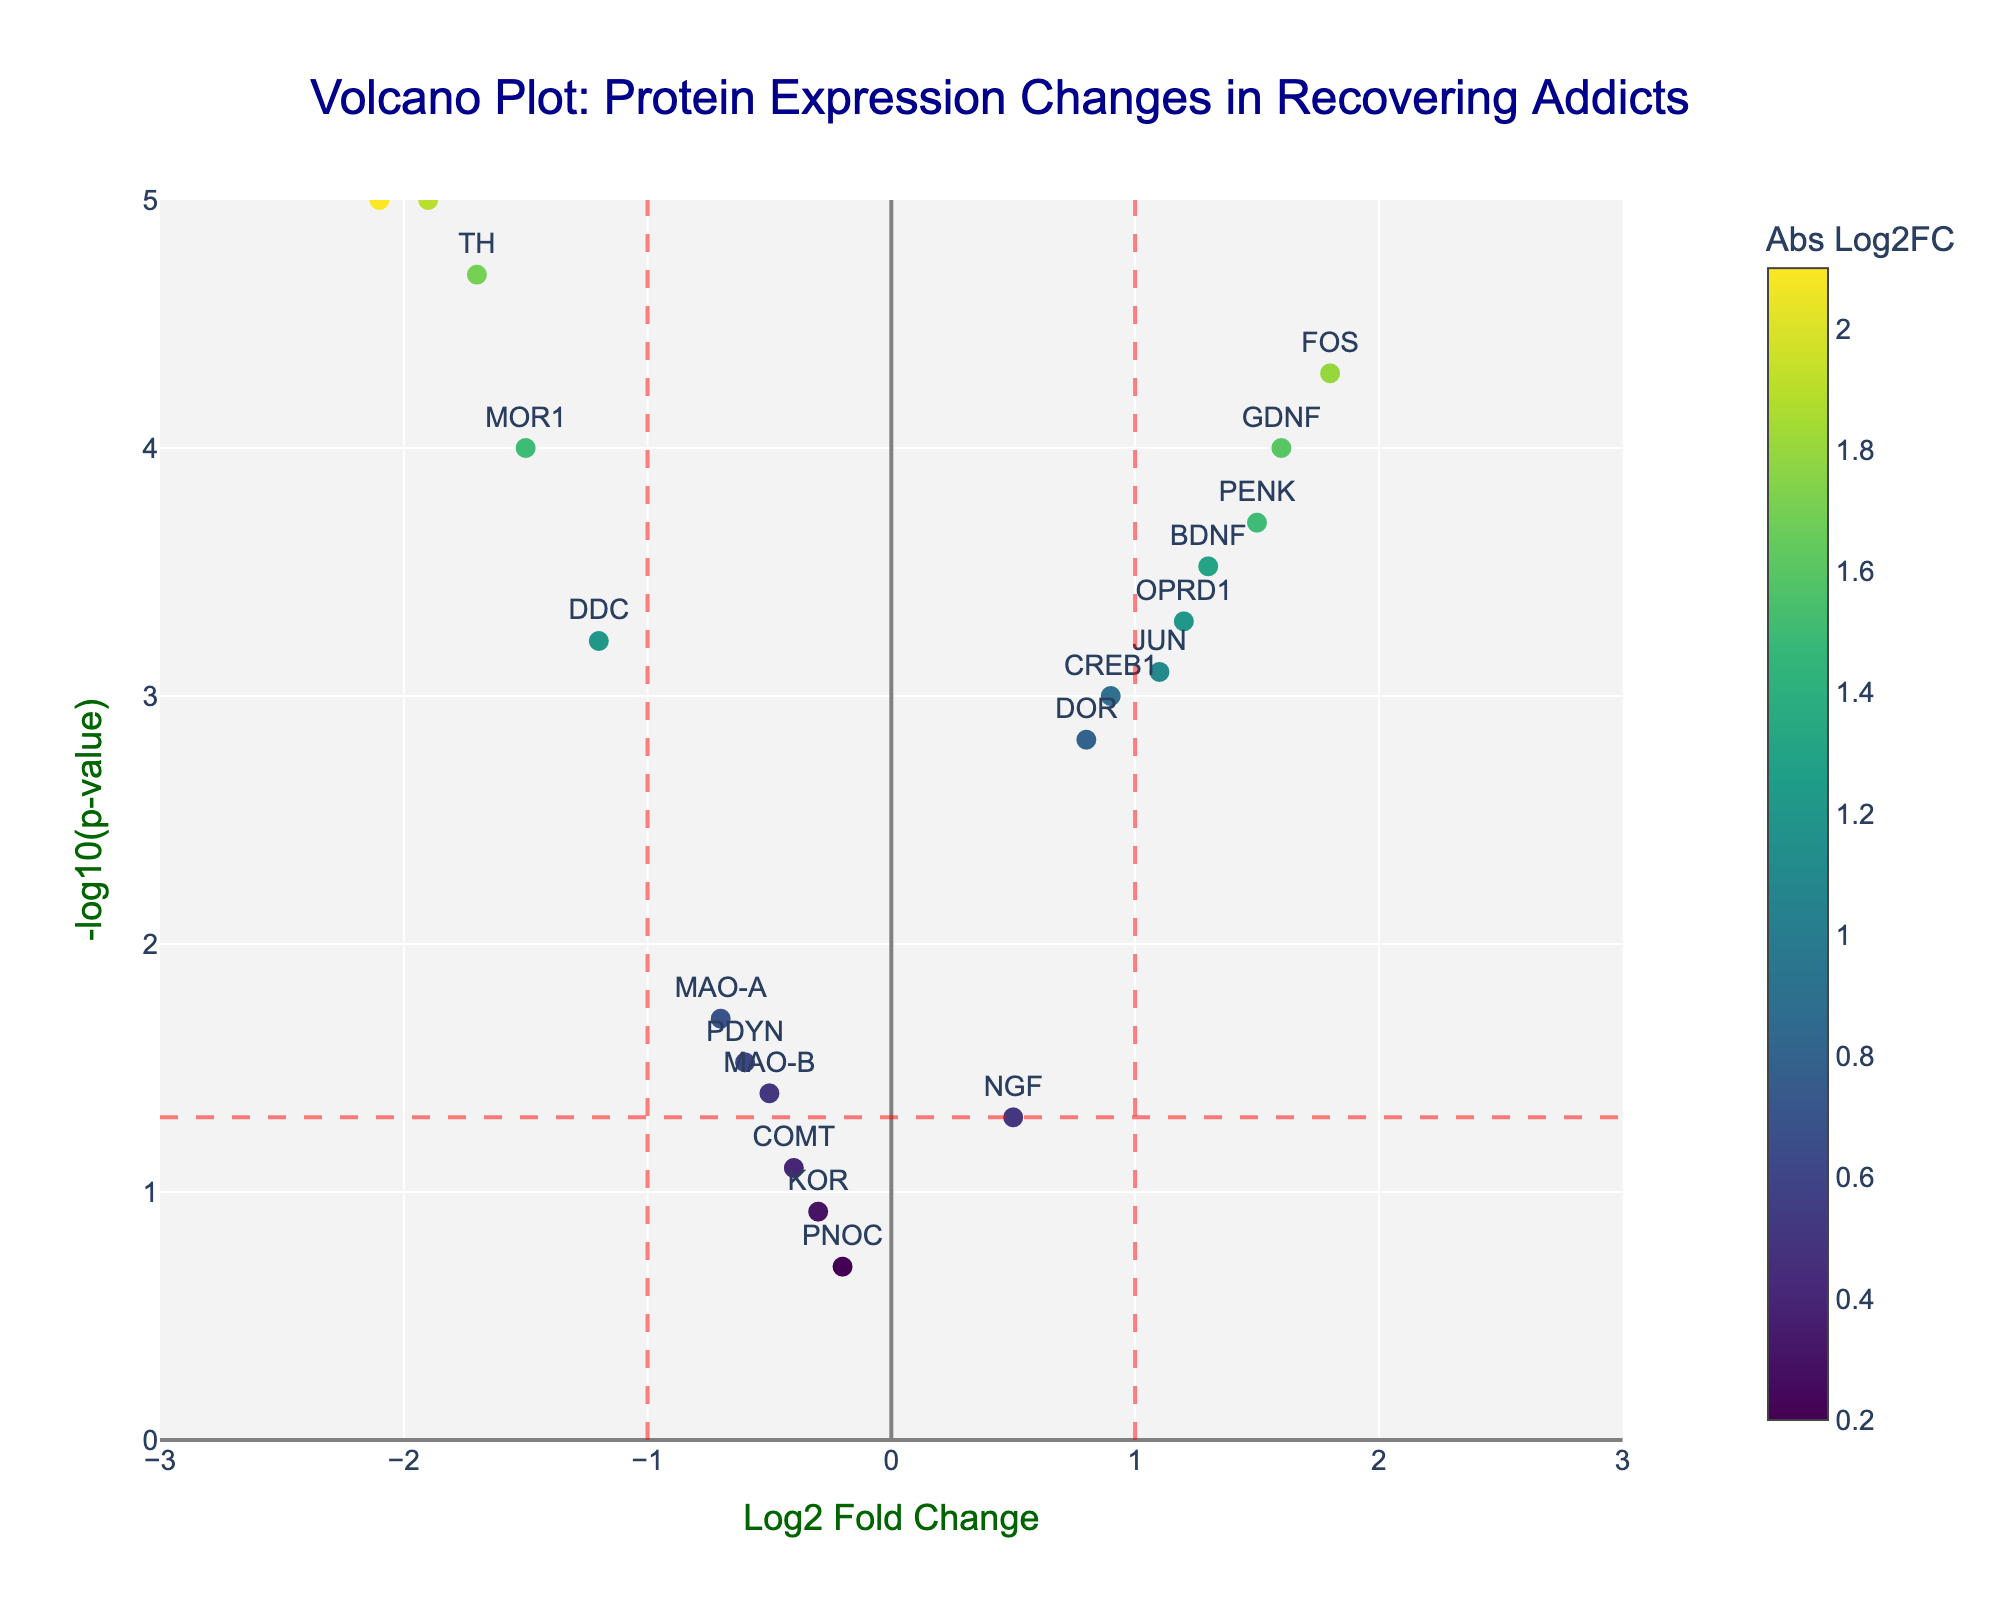Which protein shows the highest level of downregulation? The highest level of downregulation corresponds to the protein with the lowest log2 fold change value. In this case, "OPRM1" has the most negative log2 fold change at -2.1.
Answer: OPRM1 What is the threshold for significance represented by the red dashed horizontal line? The red dashed horizontal line represents the p-value threshold for significance, which is converted to -log10(p-value). Given the p-value threshold is 0.05, -log10(0.05) = 1.3.
Answer: 1.3 Which proteins are both significantly upregulated and downregulated? To be significant, the protein must lie outside the log2 fold change thresholds of ±1 and above the -log10(p-value) threshold of 1.3. The upregulated proteins are "OPRD1", "PENK", "FOS", and "GDNF", and the downregulated proteins are "OPRM1", "TH", and "DAT".
Answer: OPRD1, PENK, FOS, GDNF, OPRM1, TH, DAT How many proteins are considered not statistically significant based on the p-value? Proteins are considered not statistically significant if they lie below the -log10(p-value) threshold of 1.3. The proteins "KOR", "PDYN", "NGF", "COMT", "MAO-B", and "PNOC" fall into this category.
Answer: 6 Which protein has the smallest p-value and what is its -log10(p-value)? The smallest p-value corresponds to the largest -log10(p-value). In this case, "OPRM1" has the smallest p-value of 0.00001, which translates to -log10(0.00001) = 5.
Answer: OPRM1, 5 Comparing "FOS" and "PENK", which protein has a higher log2 fold change and by how much? "FOS" has a log2 fold change of 1.8, and "PENK" has a log2 fold change of 1.5. The difference is 1.8 - 1.5 = 0.3.
Answer: FOS, 0.3 How many proteins have a log2 fold change greater than 1? Proteins with a log2 fold change greater than 1 are "OPRD1", "PENK", "FOS", "JUN", "BDNF", and "GDNF".
Answer: 6 What does the x-axis represent in this volcano plot? The x-axis represents the log2 fold change in protein expression levels, indicating how much the expression has increased or decreased.
Answer: Log2 Fold Change Which proteins lie exactly on the log2 fold change threshold (±1)? The proteins with a log2 fold change exactly at ±1 are "OPRD1" with 1.2 and "DDC" with -1.2 (rounded).
Answer: OPRD1, DDC 